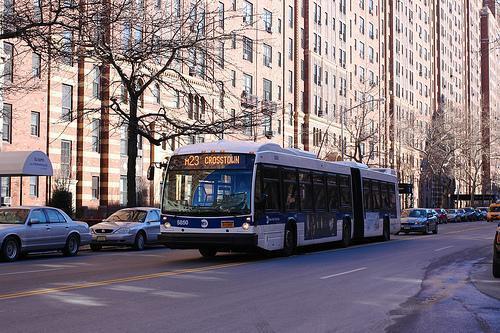How many cars are behind the bus?
Give a very brief answer. 1. 